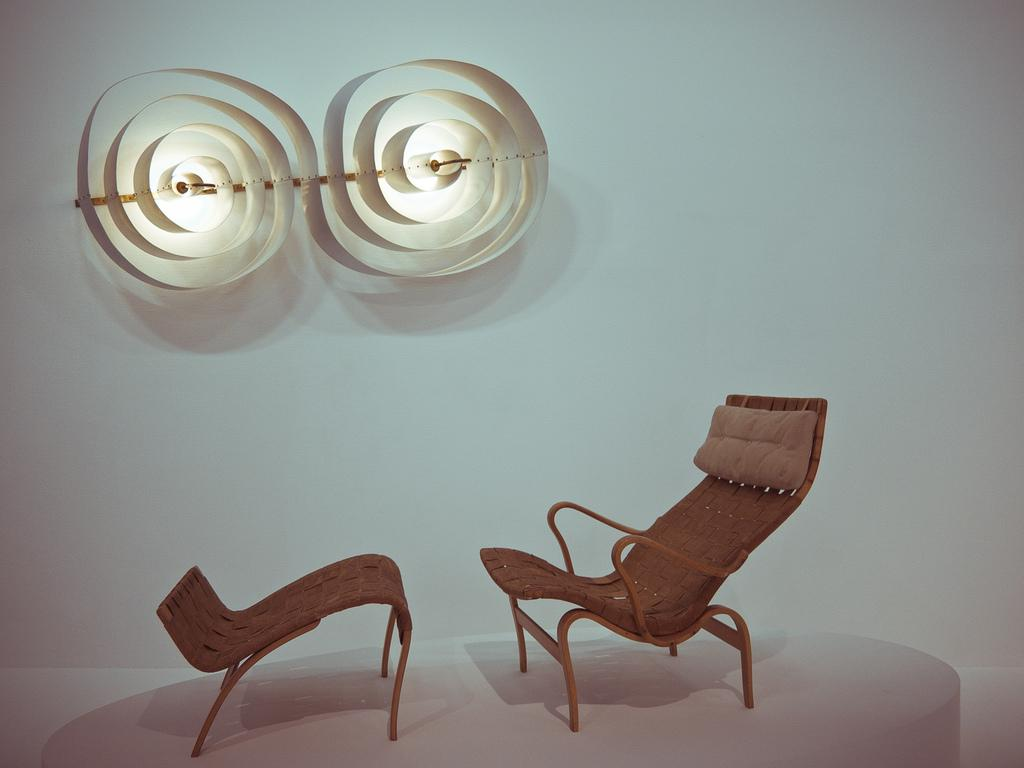What type of furniture is present in the image? There is a chair and a table in the image. What is the surface that the chair and table are placed on? The chair and table are on a white surface. How many light sources can be seen in the image? There are two lights visible in the image. What can be observed on the wall in the image? There are designs on the wall in the image. What type of statement is being made by the scale in the image? There is no scale present in the image, so no statement can be made. 